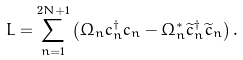Convert formula to latex. <formula><loc_0><loc_0><loc_500><loc_500>L = \sum _ { n = 1 } ^ { 2 N + 1 } \left ( \Omega _ { n } c _ { n } ^ { \dagger } c _ { n } - \Omega ^ { * } _ { n } \widetilde { c } _ { n } ^ { \dagger } \widetilde { c } _ { n } \right ) .</formula> 